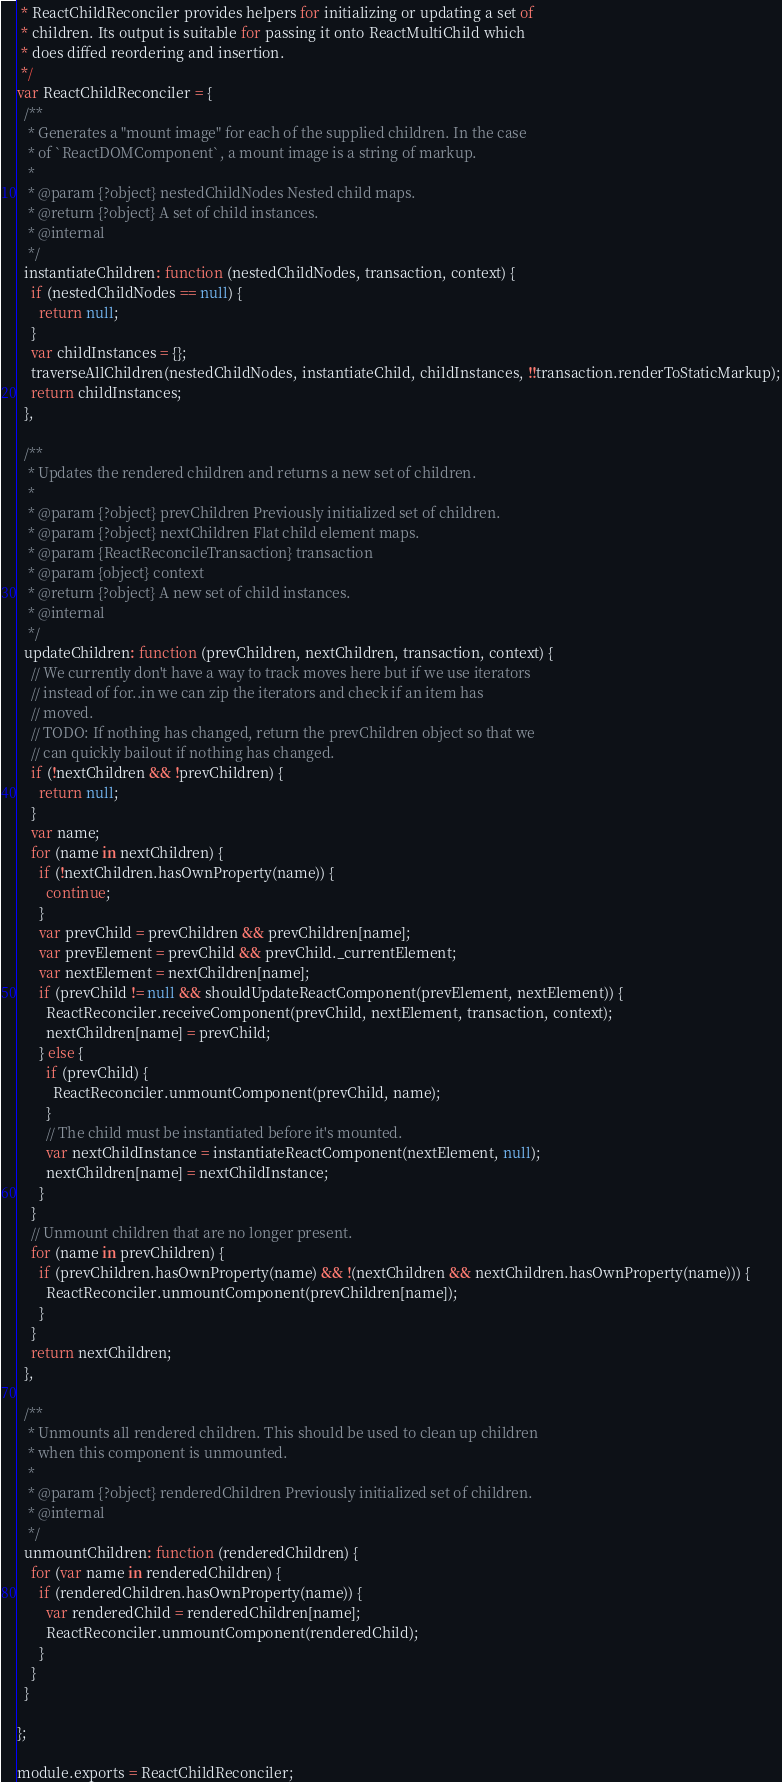<code> <loc_0><loc_0><loc_500><loc_500><_JavaScript_> * ReactChildReconciler provides helpers for initializing or updating a set of
 * children. Its output is suitable for passing it onto ReactMultiChild which
 * does diffed reordering and insertion.
 */
var ReactChildReconciler = {
  /**
   * Generates a "mount image" for each of the supplied children. In the case
   * of `ReactDOMComponent`, a mount image is a string of markup.
   *
   * @param {?object} nestedChildNodes Nested child maps.
   * @return {?object} A set of child instances.
   * @internal
   */
  instantiateChildren: function (nestedChildNodes, transaction, context) {
    if (nestedChildNodes == null) {
      return null;
    }
    var childInstances = {};
    traverseAllChildren(nestedChildNodes, instantiateChild, childInstances, !!transaction.renderToStaticMarkup);
    return childInstances;
  },

  /**
   * Updates the rendered children and returns a new set of children.
   *
   * @param {?object} prevChildren Previously initialized set of children.
   * @param {?object} nextChildren Flat child element maps.
   * @param {ReactReconcileTransaction} transaction
   * @param {object} context
   * @return {?object} A new set of child instances.
   * @internal
   */
  updateChildren: function (prevChildren, nextChildren, transaction, context) {
    // We currently don't have a way to track moves here but if we use iterators
    // instead of for..in we can zip the iterators and check if an item has
    // moved.
    // TODO: If nothing has changed, return the prevChildren object so that we
    // can quickly bailout if nothing has changed.
    if (!nextChildren && !prevChildren) {
      return null;
    }
    var name;
    for (name in nextChildren) {
      if (!nextChildren.hasOwnProperty(name)) {
        continue;
      }
      var prevChild = prevChildren && prevChildren[name];
      var prevElement = prevChild && prevChild._currentElement;
      var nextElement = nextChildren[name];
      if (prevChild != null && shouldUpdateReactComponent(prevElement, nextElement)) {
        ReactReconciler.receiveComponent(prevChild, nextElement, transaction, context);
        nextChildren[name] = prevChild;
      } else {
        if (prevChild) {
          ReactReconciler.unmountComponent(prevChild, name);
        }
        // The child must be instantiated before it's mounted.
        var nextChildInstance = instantiateReactComponent(nextElement, null);
        nextChildren[name] = nextChildInstance;
      }
    }
    // Unmount children that are no longer present.
    for (name in prevChildren) {
      if (prevChildren.hasOwnProperty(name) && !(nextChildren && nextChildren.hasOwnProperty(name))) {
        ReactReconciler.unmountComponent(prevChildren[name]);
      }
    }
    return nextChildren;
  },

  /**
   * Unmounts all rendered children. This should be used to clean up children
   * when this component is unmounted.
   *
   * @param {?object} renderedChildren Previously initialized set of children.
   * @internal
   */
  unmountChildren: function (renderedChildren) {
    for (var name in renderedChildren) {
      if (renderedChildren.hasOwnProperty(name)) {
        var renderedChild = renderedChildren[name];
        ReactReconciler.unmountComponent(renderedChild);
      }
    }
  }

};

module.exports = ReactChildReconciler;</code> 